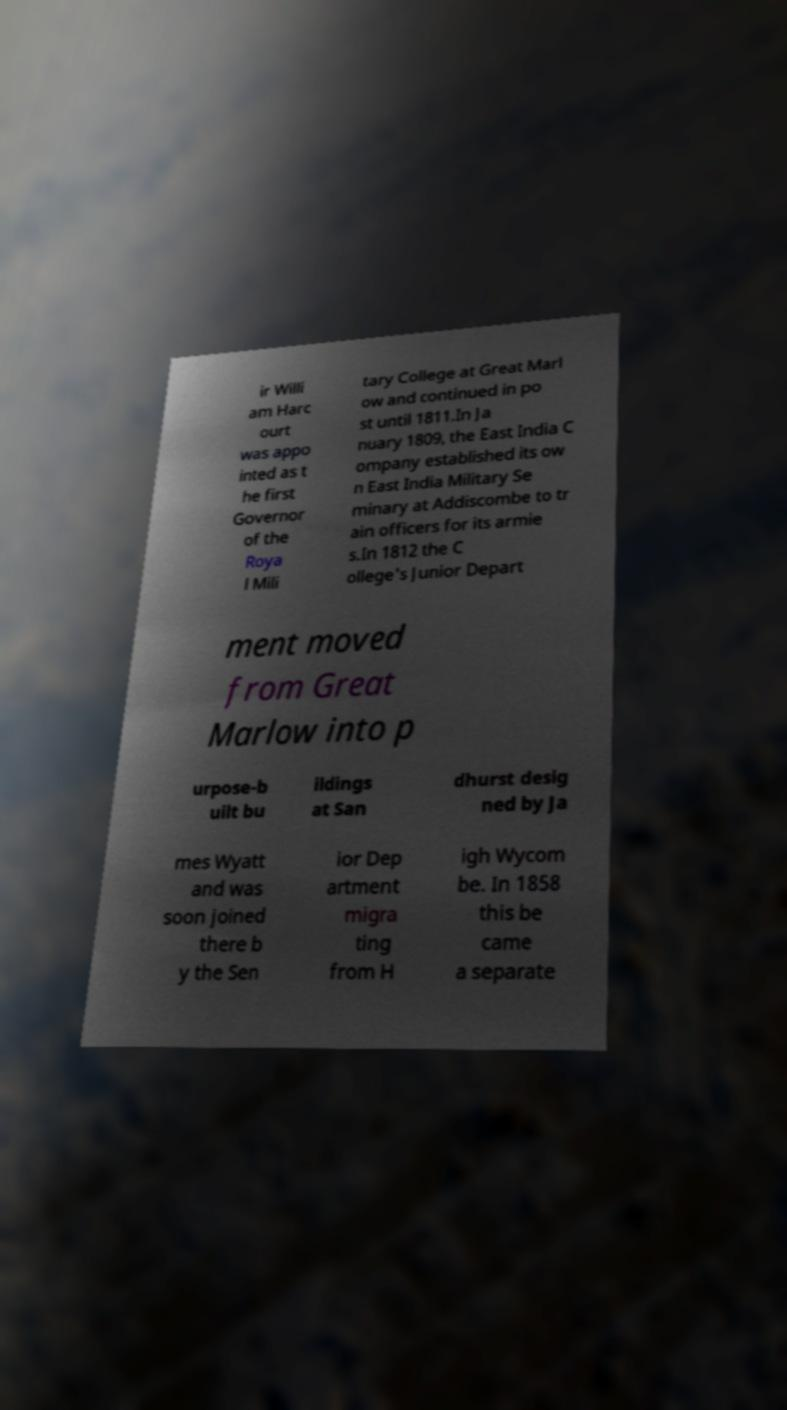Could you extract and type out the text from this image? ir Willi am Harc ourt was appo inted as t he first Governor of the Roya l Mili tary College at Great Marl ow and continued in po st until 1811.In Ja nuary 1809, the East India C ompany established its ow n East India Military Se minary at Addiscombe to tr ain officers for its armie s.In 1812 the C ollege's Junior Depart ment moved from Great Marlow into p urpose-b uilt bu ildings at San dhurst desig ned by Ja mes Wyatt and was soon joined there b y the Sen ior Dep artment migra ting from H igh Wycom be. In 1858 this be came a separate 